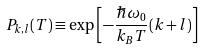Convert formula to latex. <formula><loc_0><loc_0><loc_500><loc_500>P _ { k , l } ( T ) \equiv \exp \left [ - \frac { \hbar { \omega } _ { 0 } } { k _ { B } T } ( k + l ) \right ]</formula> 